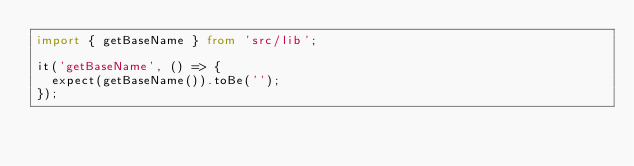Convert code to text. <code><loc_0><loc_0><loc_500><loc_500><_TypeScript_>import { getBaseName } from 'src/lib';

it('getBaseName', () => {
  expect(getBaseName()).toBe('');
});
</code> 